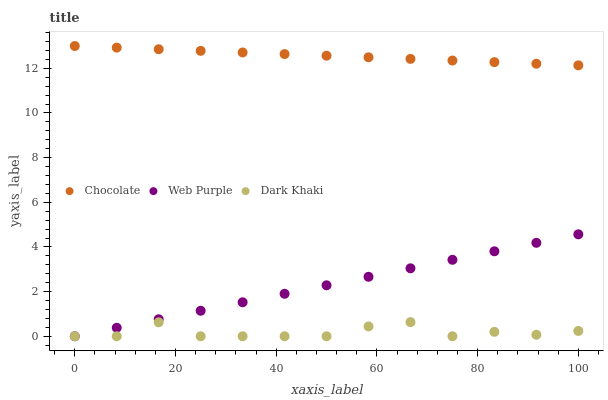Does Dark Khaki have the minimum area under the curve?
Answer yes or no. Yes. Does Chocolate have the maximum area under the curve?
Answer yes or no. Yes. Does Web Purple have the minimum area under the curve?
Answer yes or no. No. Does Web Purple have the maximum area under the curve?
Answer yes or no. No. Is Web Purple the smoothest?
Answer yes or no. Yes. Is Dark Khaki the roughest?
Answer yes or no. Yes. Is Chocolate the smoothest?
Answer yes or no. No. Is Chocolate the roughest?
Answer yes or no. No. Does Dark Khaki have the lowest value?
Answer yes or no. Yes. Does Chocolate have the lowest value?
Answer yes or no. No. Does Chocolate have the highest value?
Answer yes or no. Yes. Does Web Purple have the highest value?
Answer yes or no. No. Is Dark Khaki less than Chocolate?
Answer yes or no. Yes. Is Chocolate greater than Web Purple?
Answer yes or no. Yes. Does Web Purple intersect Dark Khaki?
Answer yes or no. Yes. Is Web Purple less than Dark Khaki?
Answer yes or no. No. Is Web Purple greater than Dark Khaki?
Answer yes or no. No. Does Dark Khaki intersect Chocolate?
Answer yes or no. No. 